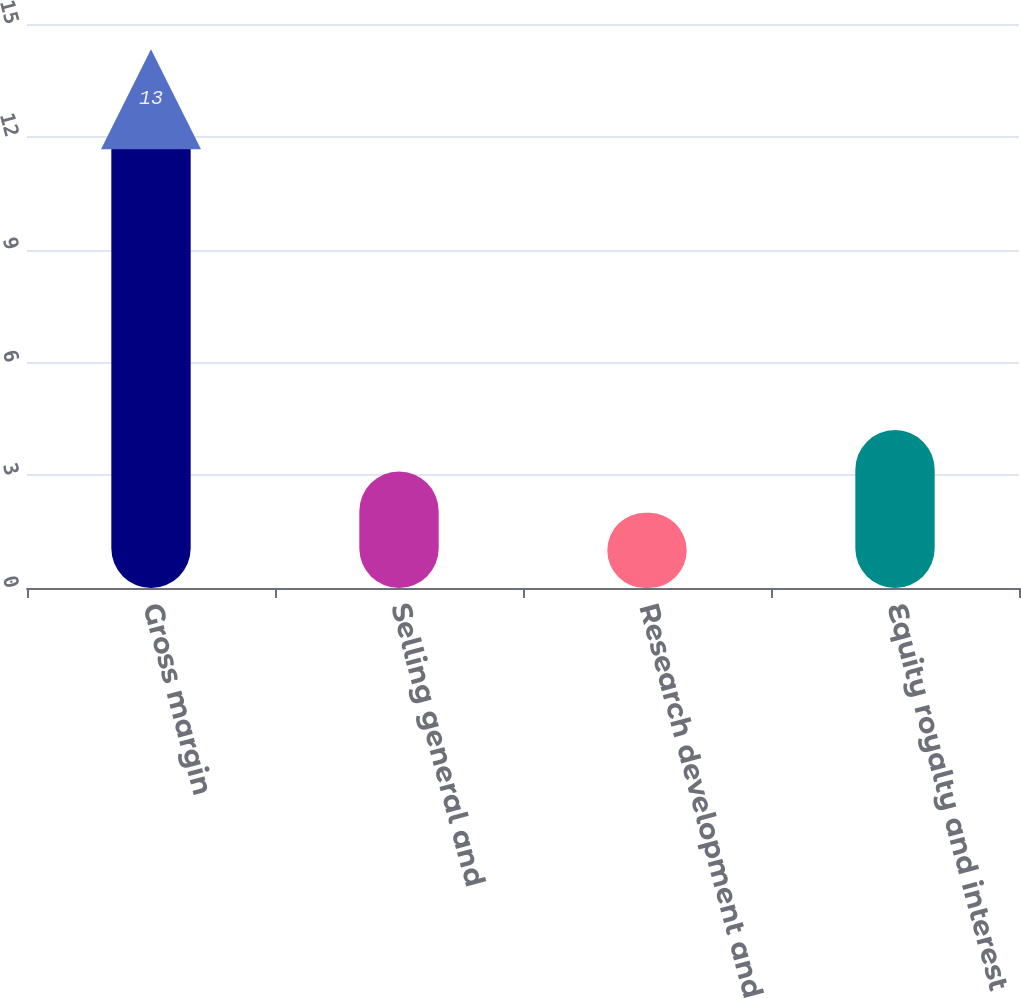<chart> <loc_0><loc_0><loc_500><loc_500><bar_chart><fcel>Gross margin<fcel>Selling general and<fcel>Research development and<fcel>Equity royalty and interest<nl><fcel>13<fcel>3.1<fcel>2<fcel>4.2<nl></chart> 